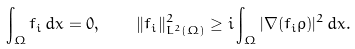Convert formula to latex. <formula><loc_0><loc_0><loc_500><loc_500>\int _ { \Omega } f _ { i } \, d x = 0 , \quad \| f _ { i } \| _ { L ^ { 2 } ( \Omega ) } ^ { 2 } \geq i \int _ { \Omega } | \nabla ( f _ { i } \rho ) | ^ { 2 } \, d x .</formula> 